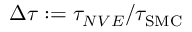<formula> <loc_0><loc_0><loc_500><loc_500>\Delta \tau \colon = \tau _ { N V E } / \tau _ { S M C }</formula> 